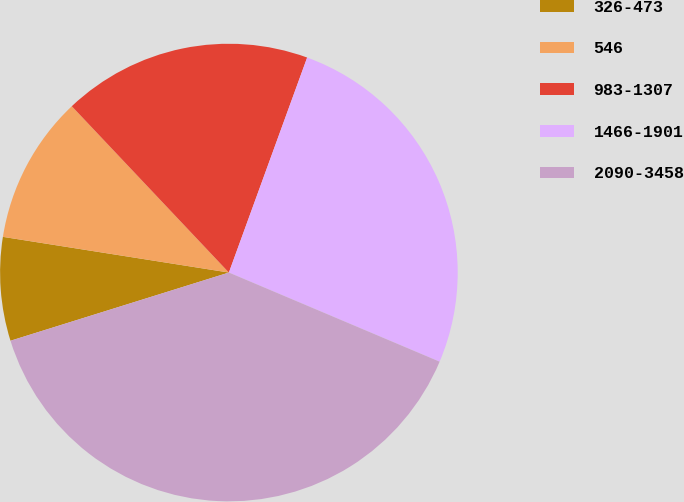Convert chart. <chart><loc_0><loc_0><loc_500><loc_500><pie_chart><fcel>326-473<fcel>546<fcel>983-1307<fcel>1466-1901<fcel>2090-3458<nl><fcel>7.31%<fcel>10.46%<fcel>17.6%<fcel>25.81%<fcel>38.81%<nl></chart> 